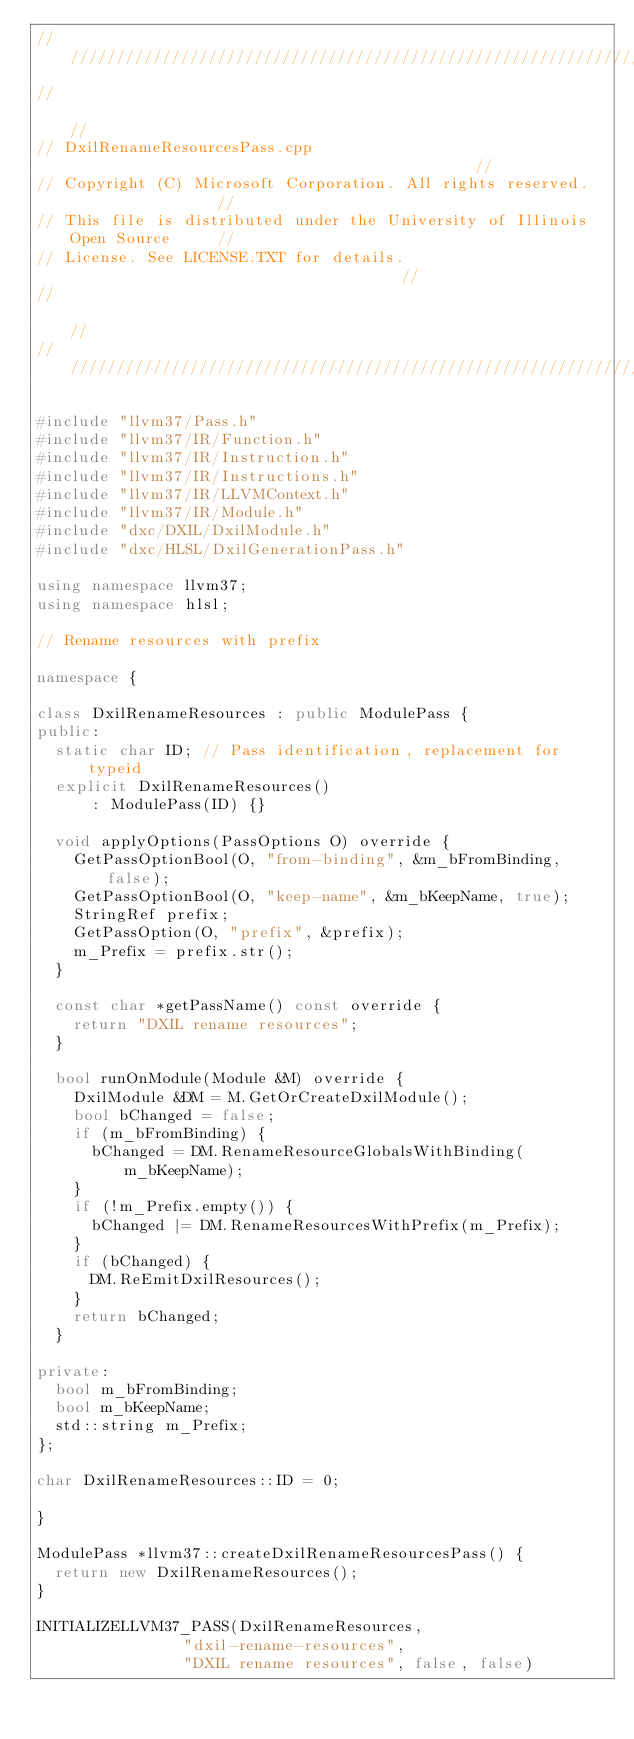Convert code to text. <code><loc_0><loc_0><loc_500><loc_500><_C++_>///////////////////////////////////////////////////////////////////////////////
//                                                                           //
// DxilRenameResourcesPass.cpp                                             //
// Copyright (C) Microsoft Corporation. All rights reserved.                 //
// This file is distributed under the University of Illinois Open Source     //
// License. See LICENSE.TXT for details.                                     //
//                                                                           //
///////////////////////////////////////////////////////////////////////////////

#include "llvm37/Pass.h"
#include "llvm37/IR/Function.h"
#include "llvm37/IR/Instruction.h"
#include "llvm37/IR/Instructions.h"
#include "llvm37/IR/LLVMContext.h"
#include "llvm37/IR/Module.h"
#include "dxc/DXIL/DxilModule.h"
#include "dxc/HLSL/DxilGenerationPass.h"

using namespace llvm37;
using namespace hlsl;

// Rename resources with prefix

namespace {

class DxilRenameResources : public ModulePass {
public:
  static char ID; // Pass identification, replacement for typeid
  explicit DxilRenameResources()
      : ModulePass(ID) {}

  void applyOptions(PassOptions O) override {
    GetPassOptionBool(O, "from-binding", &m_bFromBinding, false);
    GetPassOptionBool(O, "keep-name", &m_bKeepName, true);
    StringRef prefix;
    GetPassOption(O, "prefix", &prefix);
    m_Prefix = prefix.str();
  }

  const char *getPassName() const override {
    return "DXIL rename resources";
  }

  bool runOnModule(Module &M) override {
    DxilModule &DM = M.GetOrCreateDxilModule();
    bool bChanged = false;
    if (m_bFromBinding) {
      bChanged = DM.RenameResourceGlobalsWithBinding(m_bKeepName);
    }
    if (!m_Prefix.empty()) {
      bChanged |= DM.RenameResourcesWithPrefix(m_Prefix);
    }
    if (bChanged) {
      DM.ReEmitDxilResources();
    }
    return bChanged;
  }

private:
  bool m_bFromBinding;
  bool m_bKeepName;
  std::string m_Prefix;
};

char DxilRenameResources::ID = 0;

}

ModulePass *llvm37::createDxilRenameResourcesPass() {
  return new DxilRenameResources();
}

INITIALIZELLVM37_PASS(DxilRenameResources,
                "dxil-rename-resources",
                "DXIL rename resources", false, false)
</code> 